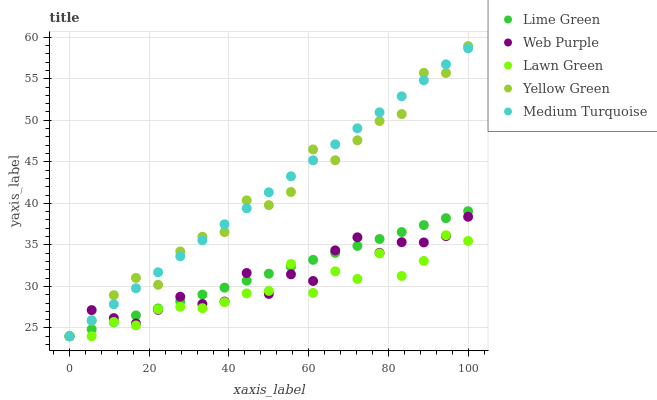Does Lawn Green have the minimum area under the curve?
Answer yes or no. Yes. Does Medium Turquoise have the maximum area under the curve?
Answer yes or no. Yes. Does Web Purple have the minimum area under the curve?
Answer yes or no. No. Does Web Purple have the maximum area under the curve?
Answer yes or no. No. Is Lime Green the smoothest?
Answer yes or no. Yes. Is Yellow Green the roughest?
Answer yes or no. Yes. Is Web Purple the smoothest?
Answer yes or no. No. Is Web Purple the roughest?
Answer yes or no. No. Does Lawn Green have the lowest value?
Answer yes or no. Yes. Does Yellow Green have the highest value?
Answer yes or no. Yes. Does Web Purple have the highest value?
Answer yes or no. No. Does Web Purple intersect Medium Turquoise?
Answer yes or no. Yes. Is Web Purple less than Medium Turquoise?
Answer yes or no. No. Is Web Purple greater than Medium Turquoise?
Answer yes or no. No. 